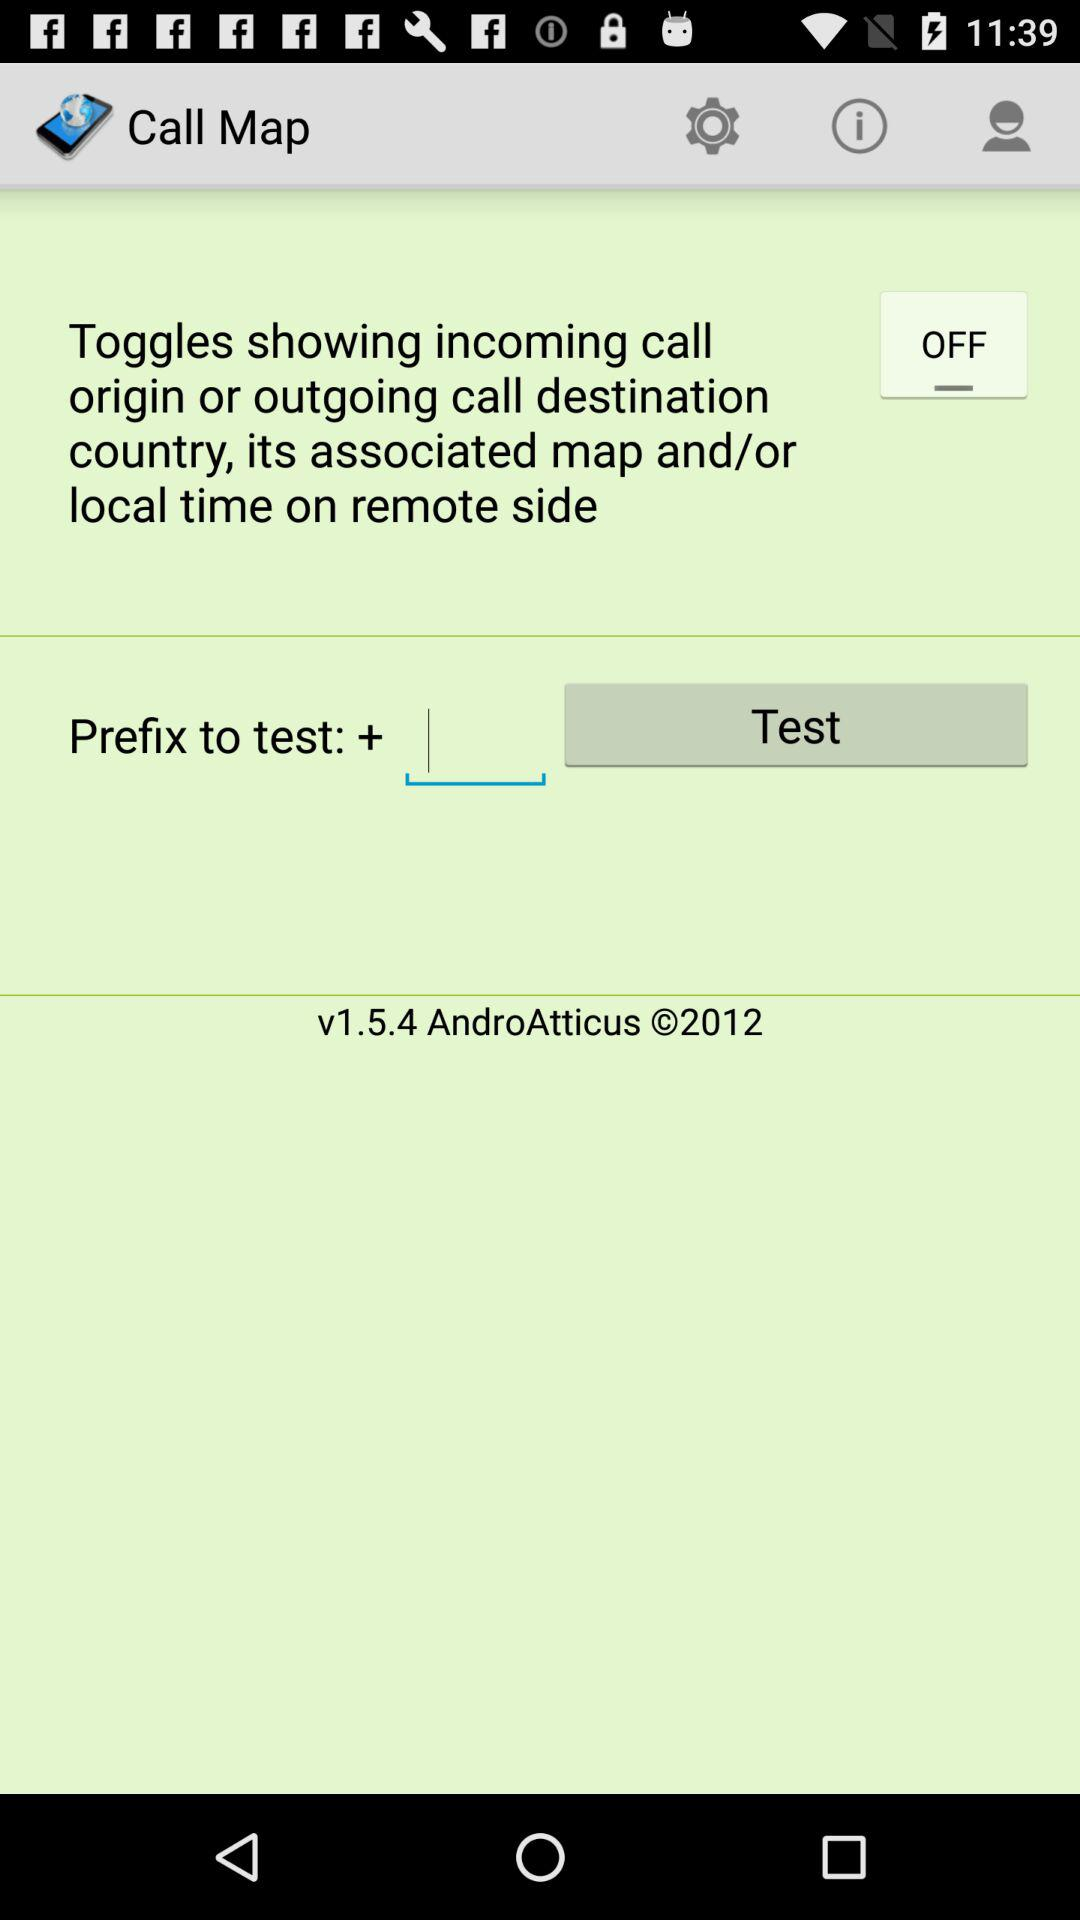What is the name of the application? The name of the application is "Call Map". 